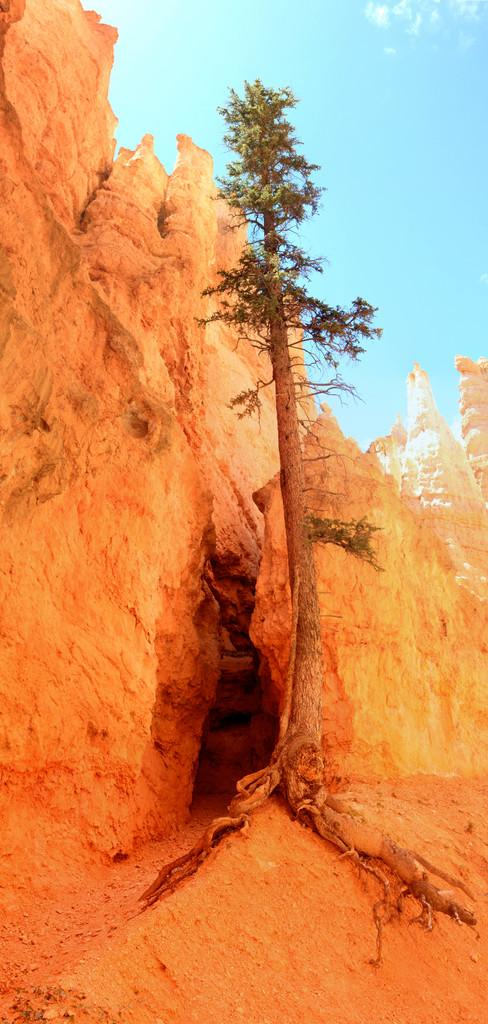What type of plant is present on the ground in the image? There is a tree on the ground in the image. What geological feature can be seen in the image? There is a cliff in the image. What part of the natural environment is visible in the background of the image? The sky is visible in the background of the image. What type of drink is being served in the image? There is no drink present in the image; it features a tree on the ground, a cliff, and the sky. What type of poetry is recited in the image? There is no poetry or recitation present in the image. 